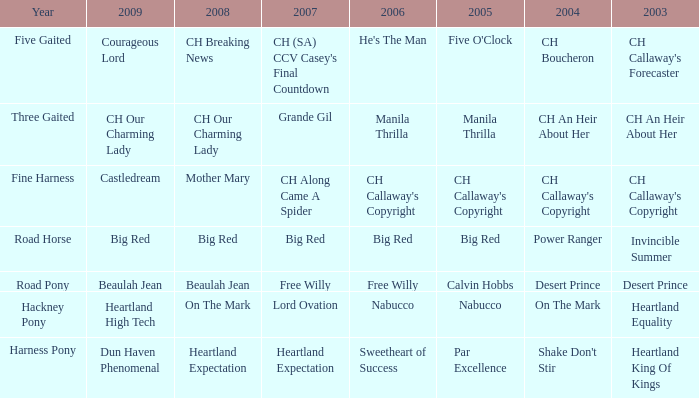In which year does the 2004 "shake don't stir" take place? Harness Pony. 